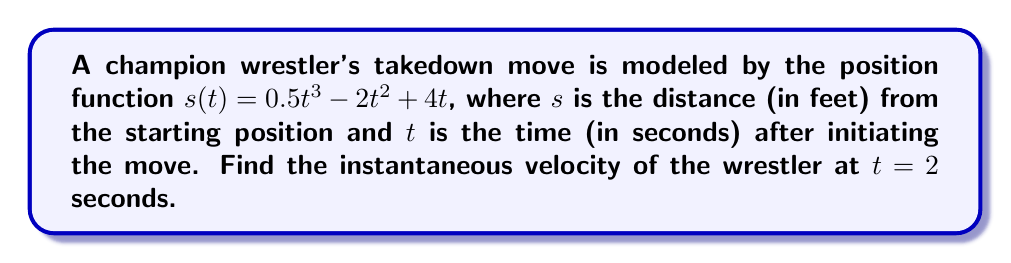Could you help me with this problem? To find the instantaneous velocity, we need to calculate the derivative of the position function and evaluate it at $t = 2$.

Step 1: Find the derivative of $s(t)$.
$$\begin{align}
s(t) &= 0.5t^3 - 2t^2 + 4t \\
v(t) = s'(t) &= 1.5t^2 - 4t + 4
\end{align}$$

Step 2: Evaluate $v(t)$ at $t = 2$.
$$\begin{align}
v(2) &= 1.5(2)^2 - 4(2) + 4 \\
&= 1.5(4) - 8 + 4 \\
&= 6 - 8 + 4 \\
&= 2
\end{align}$$

Therefore, the instantaneous velocity of the wrestler at $t = 2$ seconds is 2 feet per second.
Answer: $2$ ft/s 